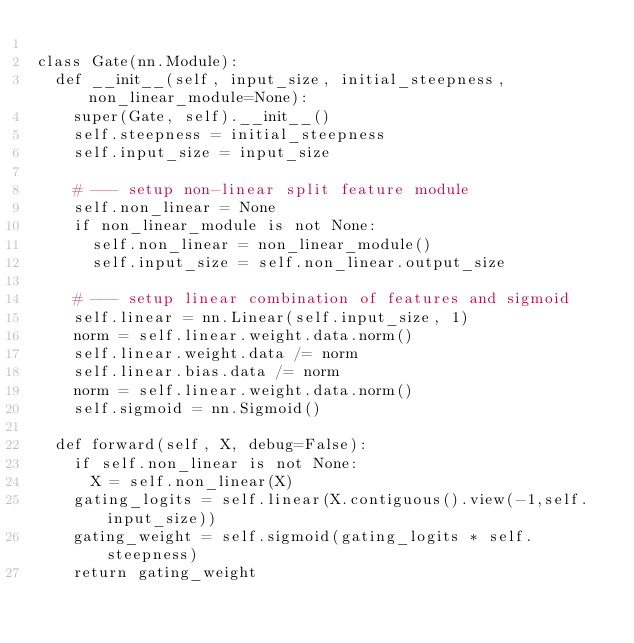Convert code to text. <code><loc_0><loc_0><loc_500><loc_500><_Python_>
class Gate(nn.Module):
  def __init__(self, input_size, initial_steepness, non_linear_module=None):
    super(Gate, self).__init__()
    self.steepness = initial_steepness
    self.input_size = input_size

    # --- setup non-linear split feature module
    self.non_linear = None
    if non_linear_module is not None:
      self.non_linear = non_linear_module()
      self.input_size = self.non_linear.output_size

    # --- setup linear combination of features and sigmoid
    self.linear = nn.Linear(self.input_size, 1)
    norm = self.linear.weight.data.norm()
    self.linear.weight.data /= norm
    self.linear.bias.data /= norm
    norm = self.linear.weight.data.norm()
    self.sigmoid = nn.Sigmoid()

  def forward(self, X, debug=False):
    if self.non_linear is not None:
      X = self.non_linear(X)
    gating_logits = self.linear(X.contiguous().view(-1,self.input_size))
    gating_weight = self.sigmoid(gating_logits * self.steepness)
    return gating_weight
</code> 